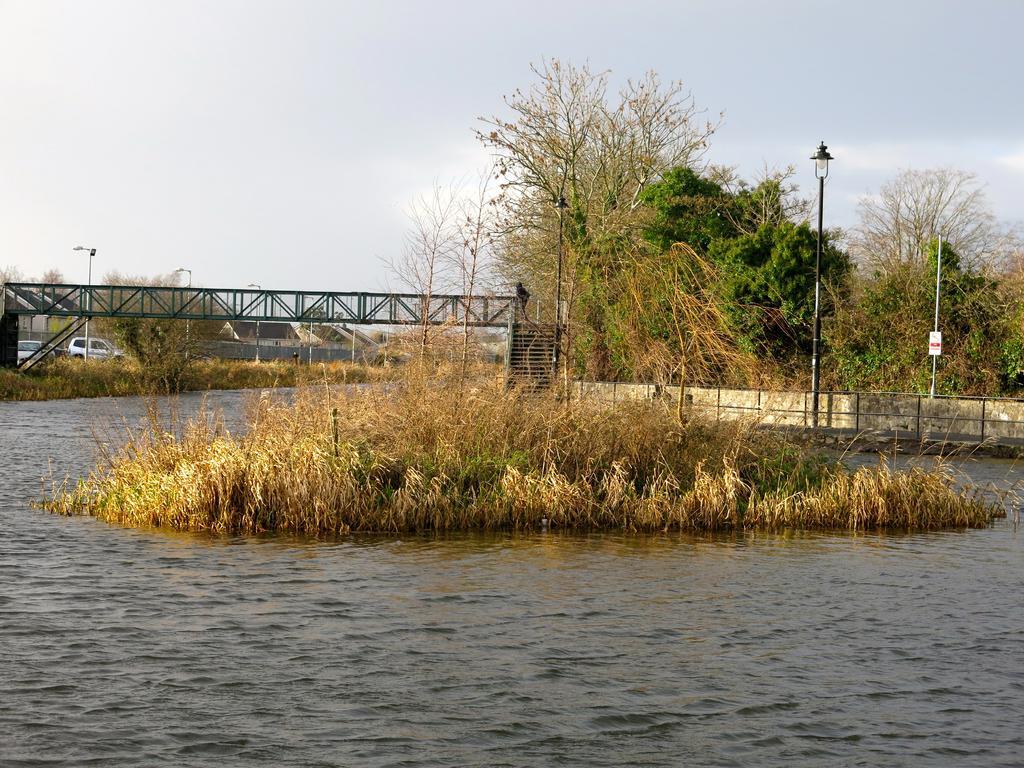Please provide a concise description of this image. In this image there is a grassy land on top of water, behind to it there is a wall. Before it there is a street light. Backside of the wall there are few trees. There is a bridge at the middle of image with staircase. Few vehicles are at left side of image. Beside to it there are few houses. Top of image there is a sky. 